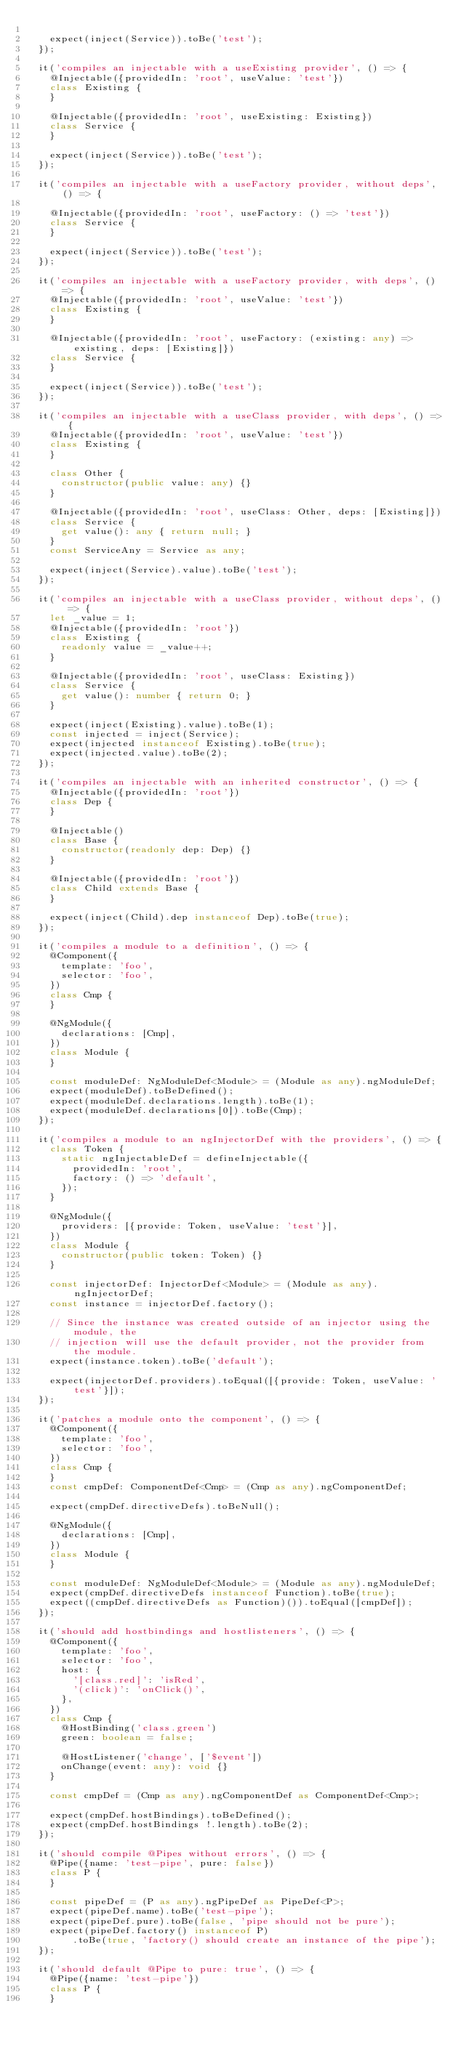<code> <loc_0><loc_0><loc_500><loc_500><_TypeScript_>
    expect(inject(Service)).toBe('test');
  });

  it('compiles an injectable with a useExisting provider', () => {
    @Injectable({providedIn: 'root', useValue: 'test'})
    class Existing {
    }

    @Injectable({providedIn: 'root', useExisting: Existing})
    class Service {
    }

    expect(inject(Service)).toBe('test');
  });

  it('compiles an injectable with a useFactory provider, without deps', () => {

    @Injectable({providedIn: 'root', useFactory: () => 'test'})
    class Service {
    }

    expect(inject(Service)).toBe('test');
  });

  it('compiles an injectable with a useFactory provider, with deps', () => {
    @Injectable({providedIn: 'root', useValue: 'test'})
    class Existing {
    }

    @Injectable({providedIn: 'root', useFactory: (existing: any) => existing, deps: [Existing]})
    class Service {
    }

    expect(inject(Service)).toBe('test');
  });

  it('compiles an injectable with a useClass provider, with deps', () => {
    @Injectable({providedIn: 'root', useValue: 'test'})
    class Existing {
    }

    class Other {
      constructor(public value: any) {}
    }

    @Injectable({providedIn: 'root', useClass: Other, deps: [Existing]})
    class Service {
      get value(): any { return null; }
    }
    const ServiceAny = Service as any;

    expect(inject(Service).value).toBe('test');
  });

  it('compiles an injectable with a useClass provider, without deps', () => {
    let _value = 1;
    @Injectable({providedIn: 'root'})
    class Existing {
      readonly value = _value++;
    }

    @Injectable({providedIn: 'root', useClass: Existing})
    class Service {
      get value(): number { return 0; }
    }

    expect(inject(Existing).value).toBe(1);
    const injected = inject(Service);
    expect(injected instanceof Existing).toBe(true);
    expect(injected.value).toBe(2);
  });

  it('compiles an injectable with an inherited constructor', () => {
    @Injectable({providedIn: 'root'})
    class Dep {
    }

    @Injectable()
    class Base {
      constructor(readonly dep: Dep) {}
    }

    @Injectable({providedIn: 'root'})
    class Child extends Base {
    }

    expect(inject(Child).dep instanceof Dep).toBe(true);
  });

  it('compiles a module to a definition', () => {
    @Component({
      template: 'foo',
      selector: 'foo',
    })
    class Cmp {
    }

    @NgModule({
      declarations: [Cmp],
    })
    class Module {
    }

    const moduleDef: NgModuleDef<Module> = (Module as any).ngModuleDef;
    expect(moduleDef).toBeDefined();
    expect(moduleDef.declarations.length).toBe(1);
    expect(moduleDef.declarations[0]).toBe(Cmp);
  });

  it('compiles a module to an ngInjectorDef with the providers', () => {
    class Token {
      static ngInjectableDef = defineInjectable({
        providedIn: 'root',
        factory: () => 'default',
      });
    }

    @NgModule({
      providers: [{provide: Token, useValue: 'test'}],
    })
    class Module {
      constructor(public token: Token) {}
    }

    const injectorDef: InjectorDef<Module> = (Module as any).ngInjectorDef;
    const instance = injectorDef.factory();

    // Since the instance was created outside of an injector using the module, the
    // injection will use the default provider, not the provider from the module.
    expect(instance.token).toBe('default');

    expect(injectorDef.providers).toEqual([{provide: Token, useValue: 'test'}]);
  });

  it('patches a module onto the component', () => {
    @Component({
      template: 'foo',
      selector: 'foo',
    })
    class Cmp {
    }
    const cmpDef: ComponentDef<Cmp> = (Cmp as any).ngComponentDef;

    expect(cmpDef.directiveDefs).toBeNull();

    @NgModule({
      declarations: [Cmp],
    })
    class Module {
    }

    const moduleDef: NgModuleDef<Module> = (Module as any).ngModuleDef;
    expect(cmpDef.directiveDefs instanceof Function).toBe(true);
    expect((cmpDef.directiveDefs as Function)()).toEqual([cmpDef]);
  });

  it('should add hostbindings and hostlisteners', () => {
    @Component({
      template: 'foo',
      selector: 'foo',
      host: {
        '[class.red]': 'isRed',
        '(click)': 'onClick()',
      },
    })
    class Cmp {
      @HostBinding('class.green')
      green: boolean = false;

      @HostListener('change', ['$event'])
      onChange(event: any): void {}
    }

    const cmpDef = (Cmp as any).ngComponentDef as ComponentDef<Cmp>;

    expect(cmpDef.hostBindings).toBeDefined();
    expect(cmpDef.hostBindings !.length).toBe(2);
  });

  it('should compile @Pipes without errors', () => {
    @Pipe({name: 'test-pipe', pure: false})
    class P {
    }

    const pipeDef = (P as any).ngPipeDef as PipeDef<P>;
    expect(pipeDef.name).toBe('test-pipe');
    expect(pipeDef.pure).toBe(false, 'pipe should not be pure');
    expect(pipeDef.factory() instanceof P)
        .toBe(true, 'factory() should create an instance of the pipe');
  });

  it('should default @Pipe to pure: true', () => {
    @Pipe({name: 'test-pipe'})
    class P {
    }
</code> 